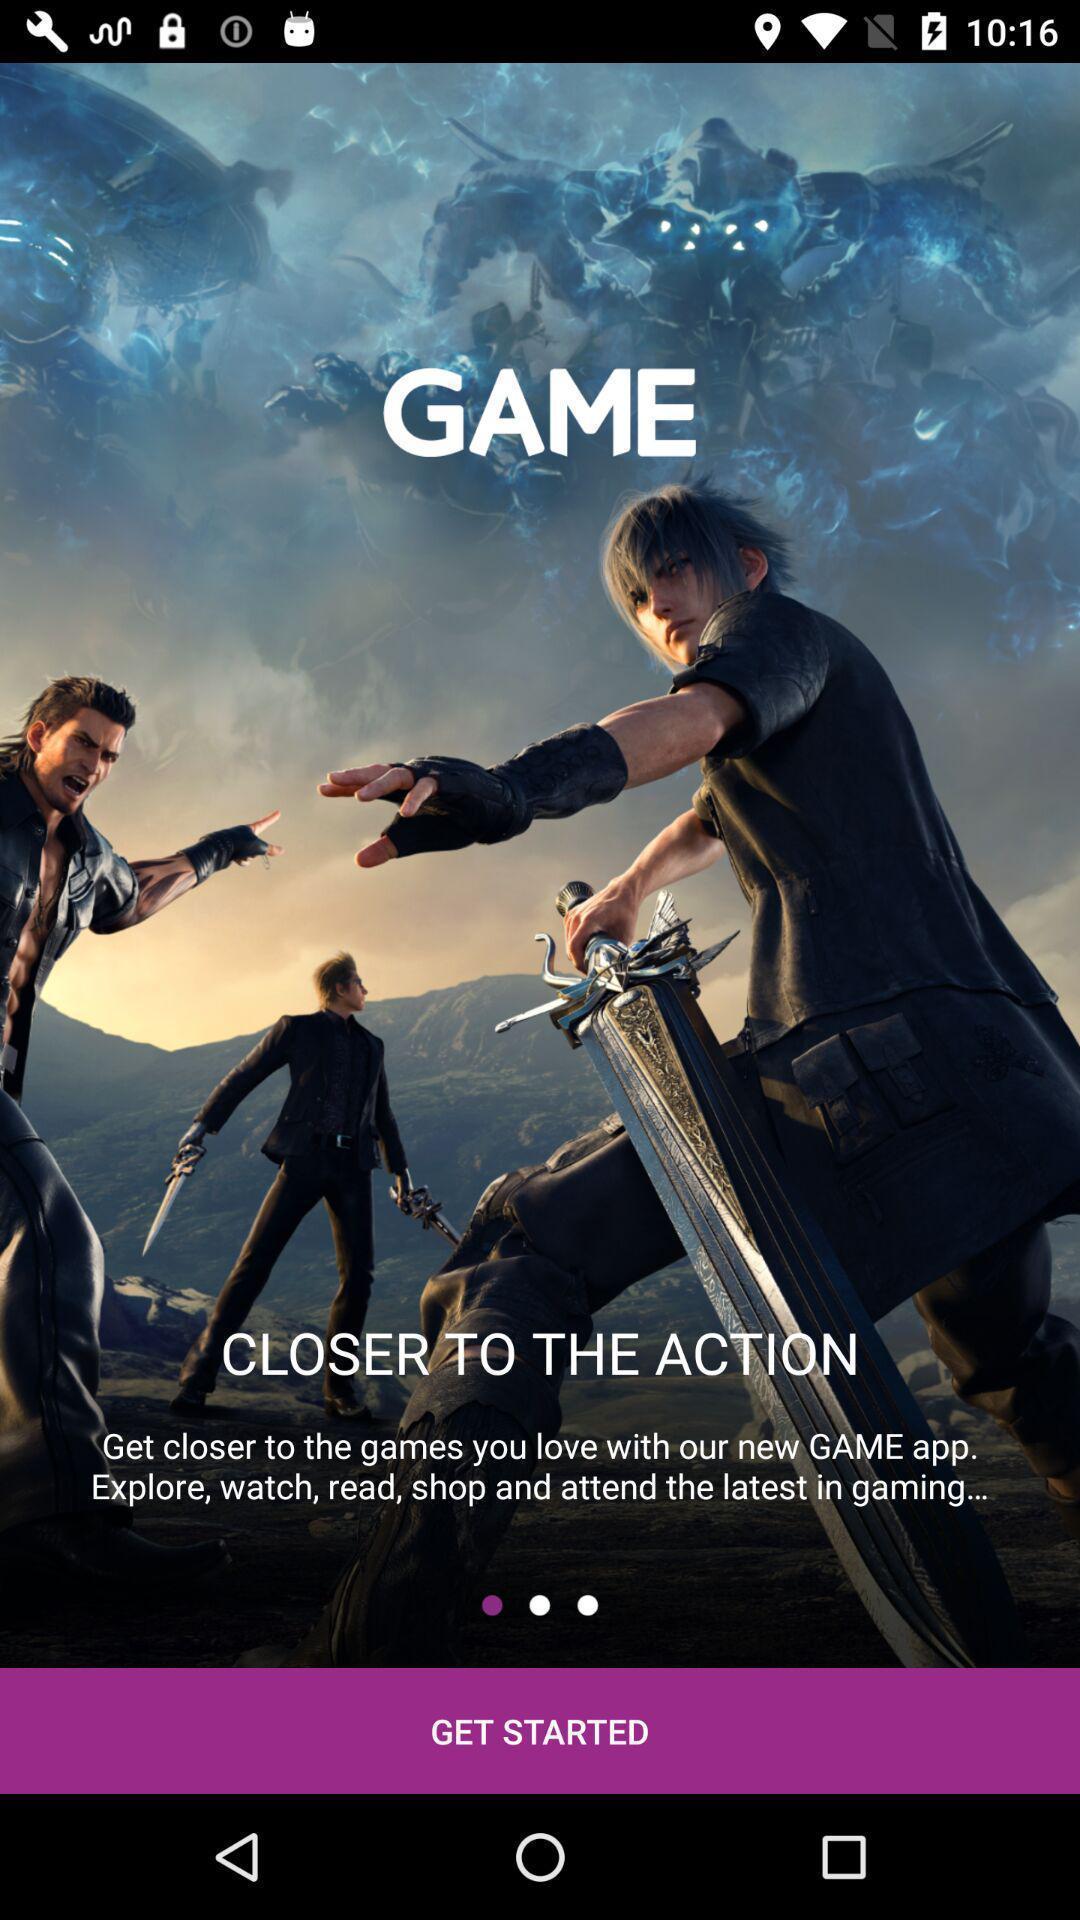Give me a narrative description of this picture. Welcome page of gaming app. 